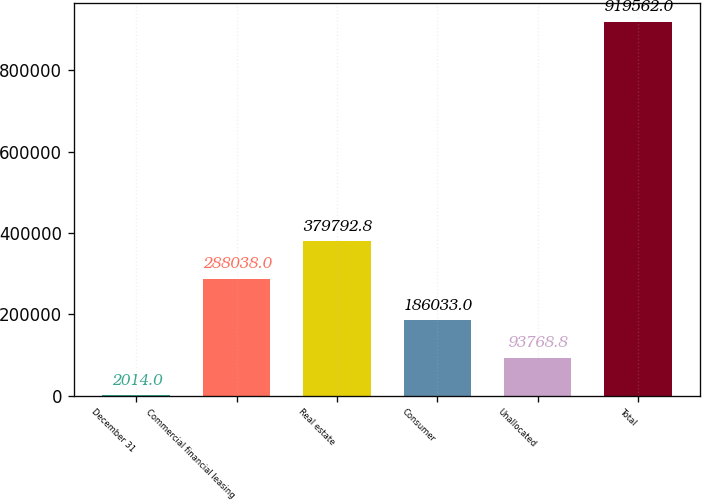<chart> <loc_0><loc_0><loc_500><loc_500><bar_chart><fcel>December 31<fcel>Commercial financial leasing<fcel>Real estate<fcel>Consumer<fcel>Unallocated<fcel>Total<nl><fcel>2014<fcel>288038<fcel>379793<fcel>186033<fcel>93768.8<fcel>919562<nl></chart> 